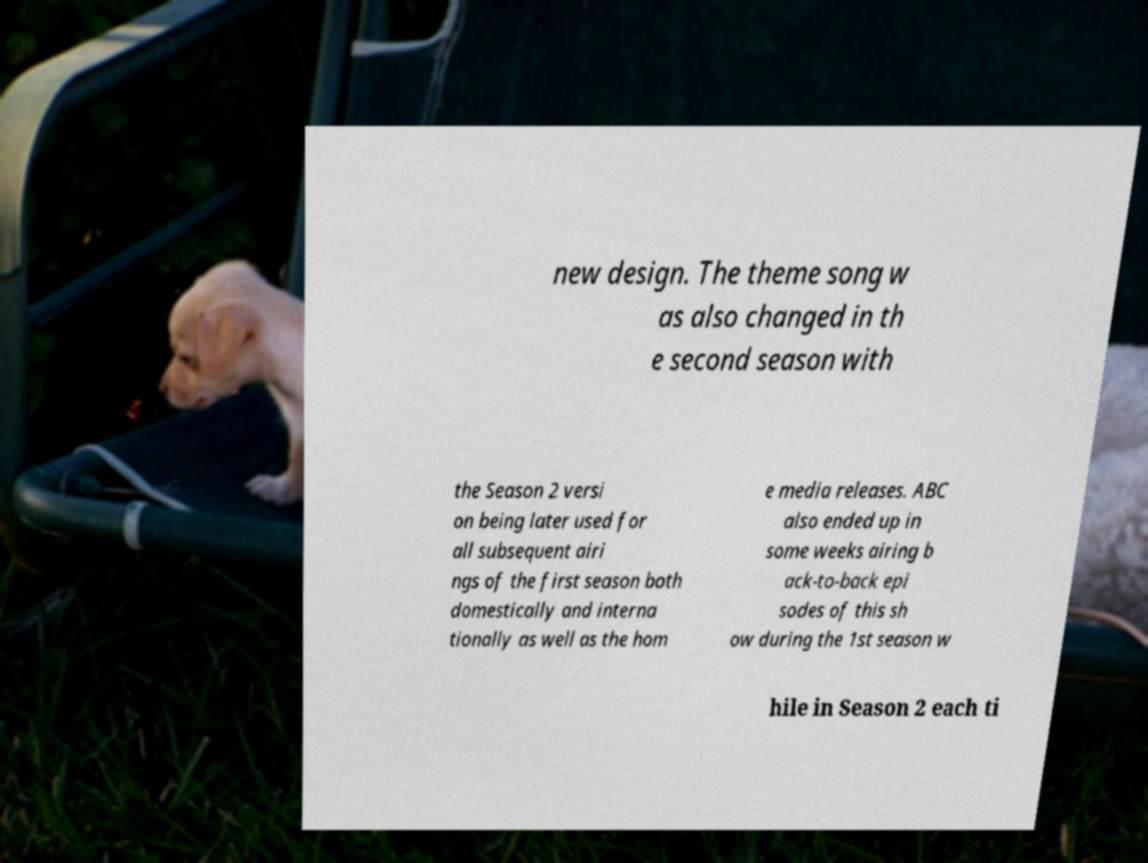Please read and relay the text visible in this image. What does it say? new design. The theme song w as also changed in th e second season with the Season 2 versi on being later used for all subsequent airi ngs of the first season both domestically and interna tionally as well as the hom e media releases. ABC also ended up in some weeks airing b ack-to-back epi sodes of this sh ow during the 1st season w hile in Season 2 each ti 